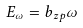Convert formula to latex. <formula><loc_0><loc_0><loc_500><loc_500>E _ { \omega } = b _ { z p } \omega</formula> 